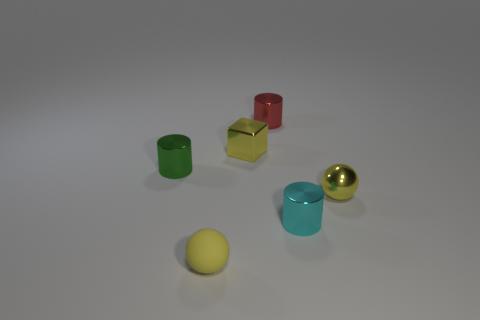How many other tiny green objects have the same shape as the tiny green thing?
Ensure brevity in your answer.  0. Is the color of the tiny ball that is left of the red object the same as the sphere on the right side of the red cylinder?
Provide a succinct answer. Yes. How many objects are either tiny yellow balls or tiny red shiny cylinders?
Provide a succinct answer. 3. What number of tiny yellow things are made of the same material as the small green object?
Ensure brevity in your answer.  2. Are there fewer tiny cyan metal cylinders than large rubber cubes?
Your response must be concise. No. Is the small ball left of the tiny cyan metallic thing made of the same material as the small cyan thing?
Your response must be concise. No. What number of balls are either small red metallic objects or matte objects?
Provide a succinct answer. 1. What shape is the small thing that is both behind the yellow rubber ball and in front of the metal ball?
Provide a short and direct response. Cylinder. What is the color of the ball to the right of the yellow ball that is left of the metal cylinder that is behind the small green thing?
Provide a short and direct response. Yellow. Is the number of things that are behind the small yellow cube less than the number of tiny yellow cubes?
Make the answer very short. No. 